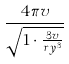<formula> <loc_0><loc_0><loc_500><loc_500>\frac { 4 \pi v } { \sqrt { 1 \cdot \frac { 3 v } { r y ^ { 3 } } } }</formula> 